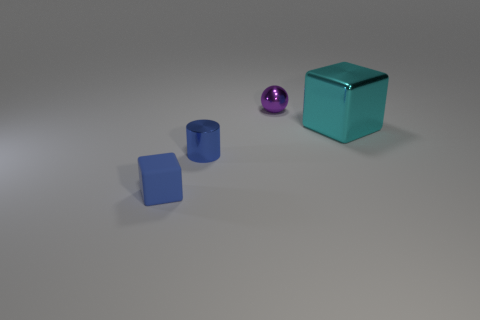Add 2 things. How many objects exist? 6 Subtract all cylinders. How many objects are left? 3 Add 4 small purple metal cylinders. How many small purple metal cylinders exist? 4 Subtract 0 green cylinders. How many objects are left? 4 Subtract all gray shiny spheres. Subtract all tiny spheres. How many objects are left? 3 Add 1 cubes. How many cubes are left? 3 